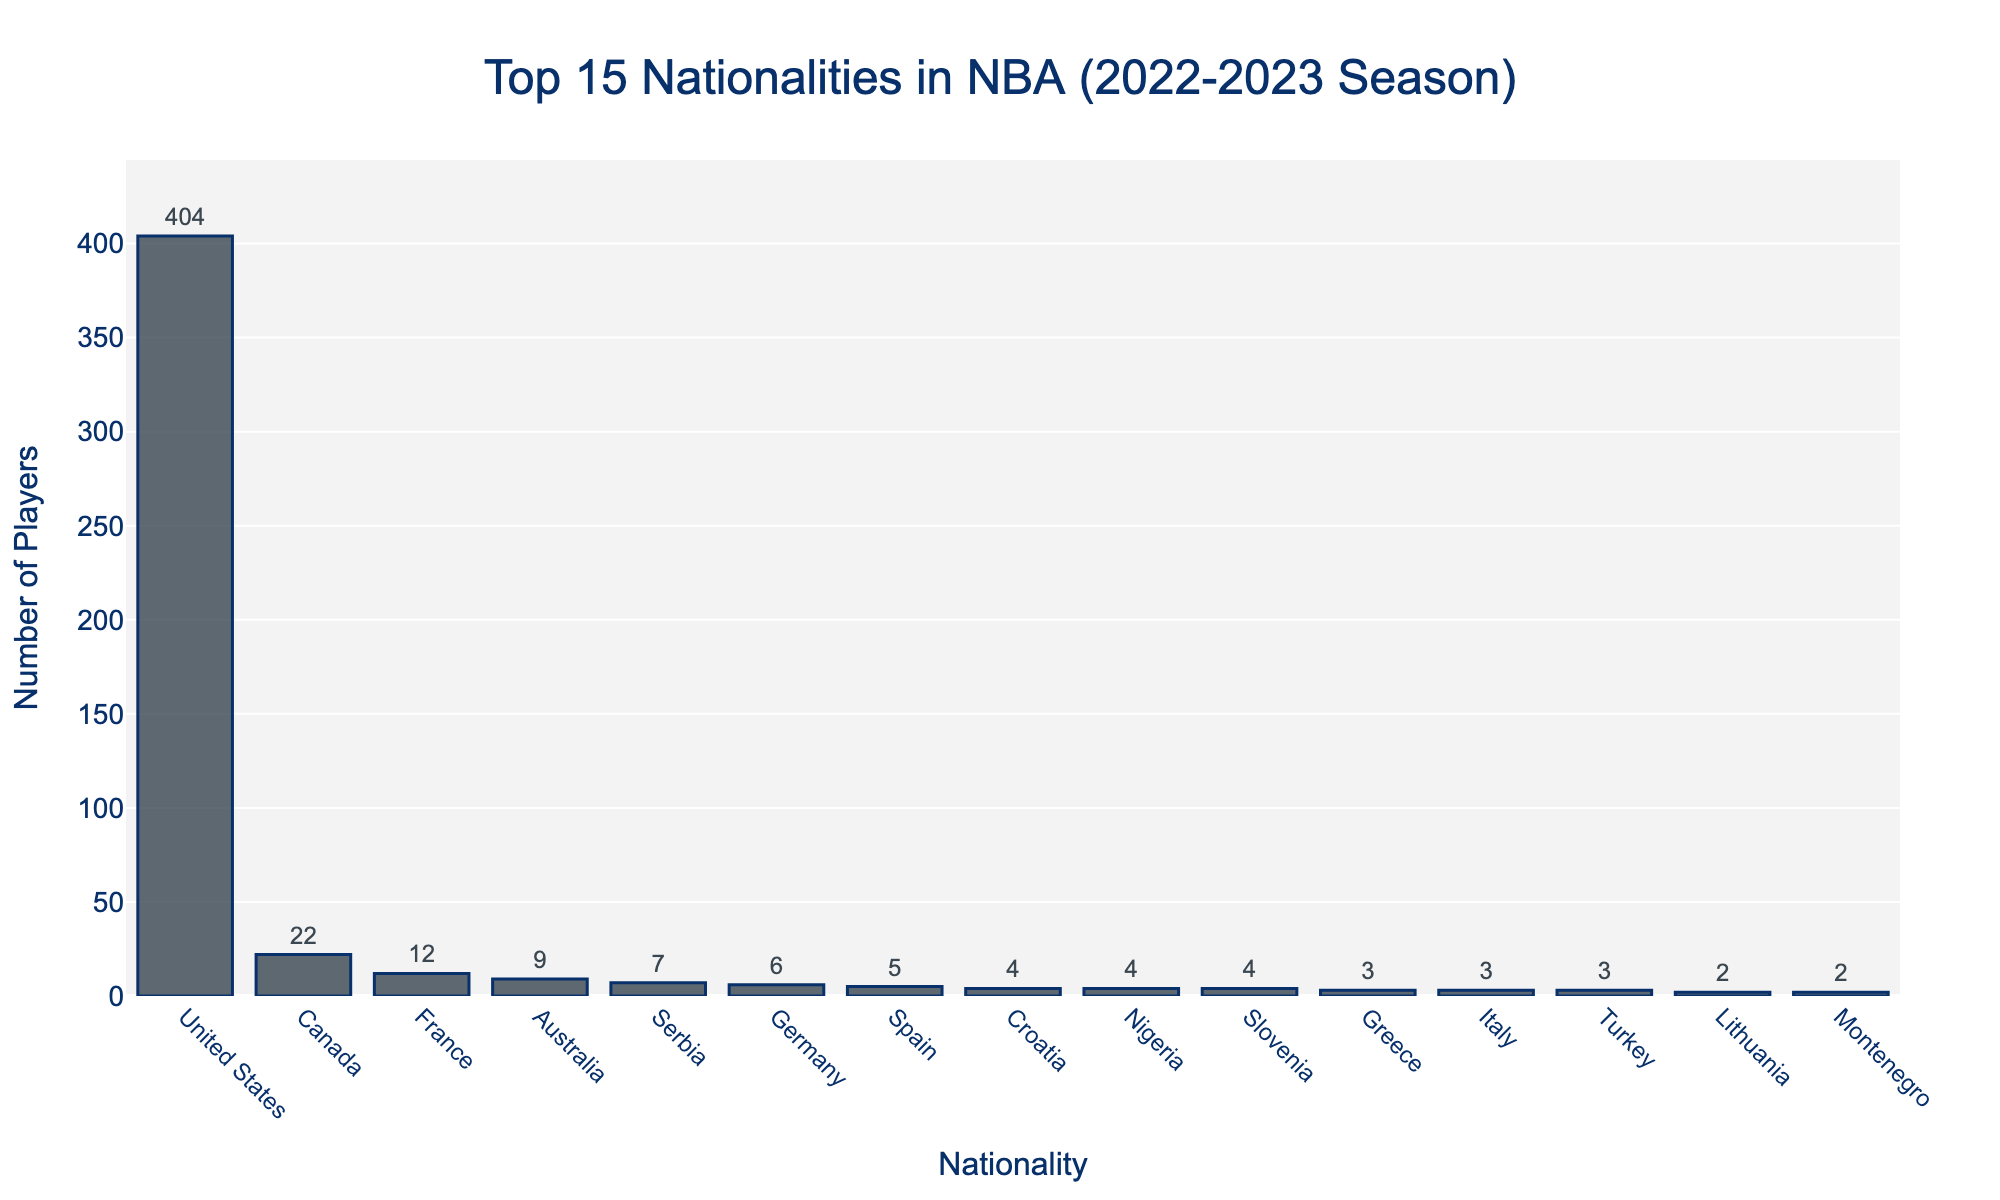What is the nationality with the highest number of players in the NBA for the 2022-2023 season? By looking at the figure, the bar representing the United States is the tallest, indicating the highest number of players.
Answer: United States What is the sum of the number of NBA players from Canada and France in the 2022-2023 season? The chart shows 22 players from Canada and 12 players from France. Adding these numbers gives 22 + 12 = 34.
Answer: 34 Which nationalities have an equal number of NBA players, all having 4 players? The chart shows Croatia, Nigeria, and Slovenia all have bars of the same height, corresponding to 4 players each.
Answer: Croatia, Nigeria, Slovenia How does the number of NBA players from Australia compare to Serbia in the 2022-2023 season? By comparing the heights of the bars, we see that Australia has a taller bar with 9 players, and Serbia has a shorter bar with 7 players. Therefore, Australia has more players than Serbia.
Answer: Australia has more players What percentage of the total players in the top 15 nationalities list are from the United States? Sum the number of players in the top 15: 404 (USA) + 22 (Canada) + 12 (France) + 9 (Australia) + 7 (Serbia) + 6 (Germany) + 5 (Spain) + 4 (Croatia) + 4 (Nigeria) + 4 (Slovenia) + 3 (Greece) + 3 (Italy) + 3 (Turkey) + 2 (Argentina) + 2 (Brazil). The total is 486. Then, calculate the percentage: (404 / 486) * 100 ≈ 83.13%.
Answer: 83.13% What is the difference in the number of NBA players between the top two nationalities? The figure shows that the United States has 404 players and Canada has 22 players. Therefore, the difference is 404 - 22 = 382.
Answer: 382 Which country has the smallest number of players among the top 15 represented nationalities? The figures show that Argentina and Brazil both have the shortest bars representing 2 players each.
Answer: Argentina, Brazil Do Germany and Spain together have more NBA players than Canada? Germany has 6 players and Spain has 5 players. Together they have 6 + 5 = 11 players. Canada has 22 players. Since 11 is less than 22, Germany and Spain together have fewer players than Canada.
Answer: No What is the average number of NBA players for the top 5 nationalities? The top 5 nationalities are the United States (404), Canada (22), France (12), Australia (9), and Serbia (7). Sum these numbers: 404 + 22 + 12 + 9 + 7 = 454. Then, divide by 5: 454 / 5 = 90.8.
Answer: 90.8 